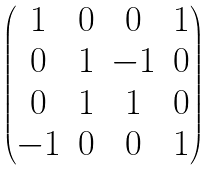Convert formula to latex. <formula><loc_0><loc_0><loc_500><loc_500>\begin{pmatrix} 1 & 0 & 0 & 1 \\ 0 & 1 & - 1 & 0 \\ 0 & 1 & 1 & 0 \\ - 1 & 0 & 0 & 1 \end{pmatrix}</formula> 